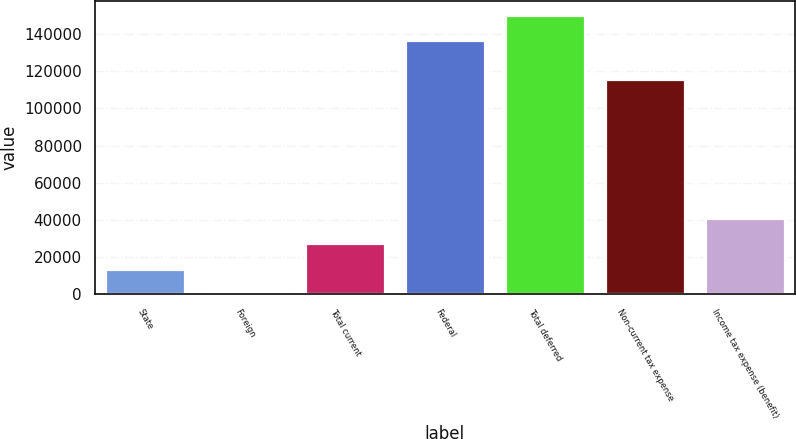Convert chart. <chart><loc_0><loc_0><loc_500><loc_500><bar_chart><fcel>State<fcel>Foreign<fcel>Total current<fcel>Federal<fcel>Total deferred<fcel>Non-current tax expense<fcel>Income tax expense (benefit)<nl><fcel>13854.3<fcel>163<fcel>27545.6<fcel>136877<fcel>150568<fcel>116104<fcel>41236.9<nl></chart> 